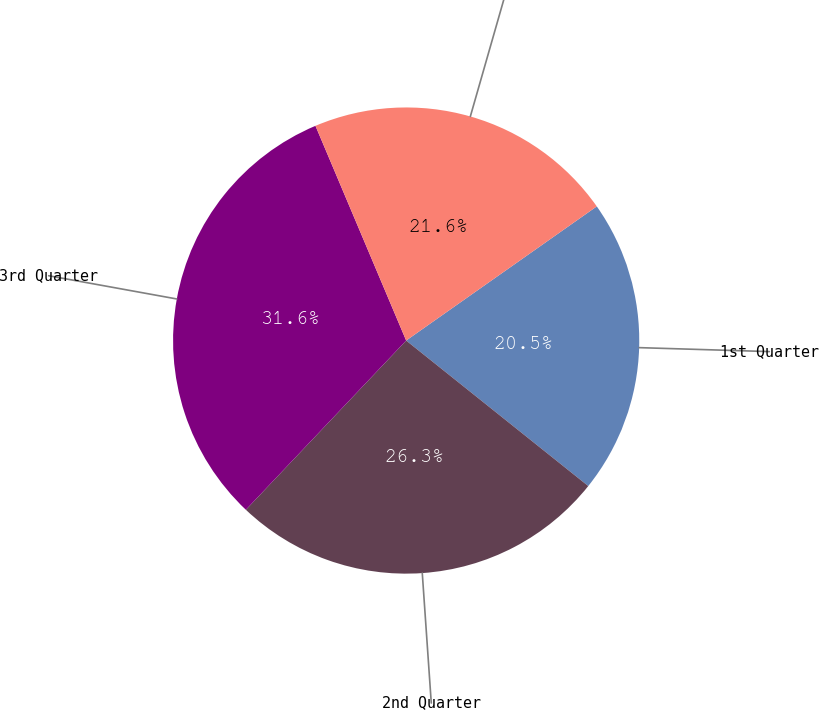Convert chart to OTSL. <chart><loc_0><loc_0><loc_500><loc_500><pie_chart><fcel>1st Quarter<fcel>2nd Quarter<fcel>3rd Quarter<fcel>4th Quarter<nl><fcel>20.49%<fcel>26.34%<fcel>31.57%<fcel>21.6%<nl></chart> 